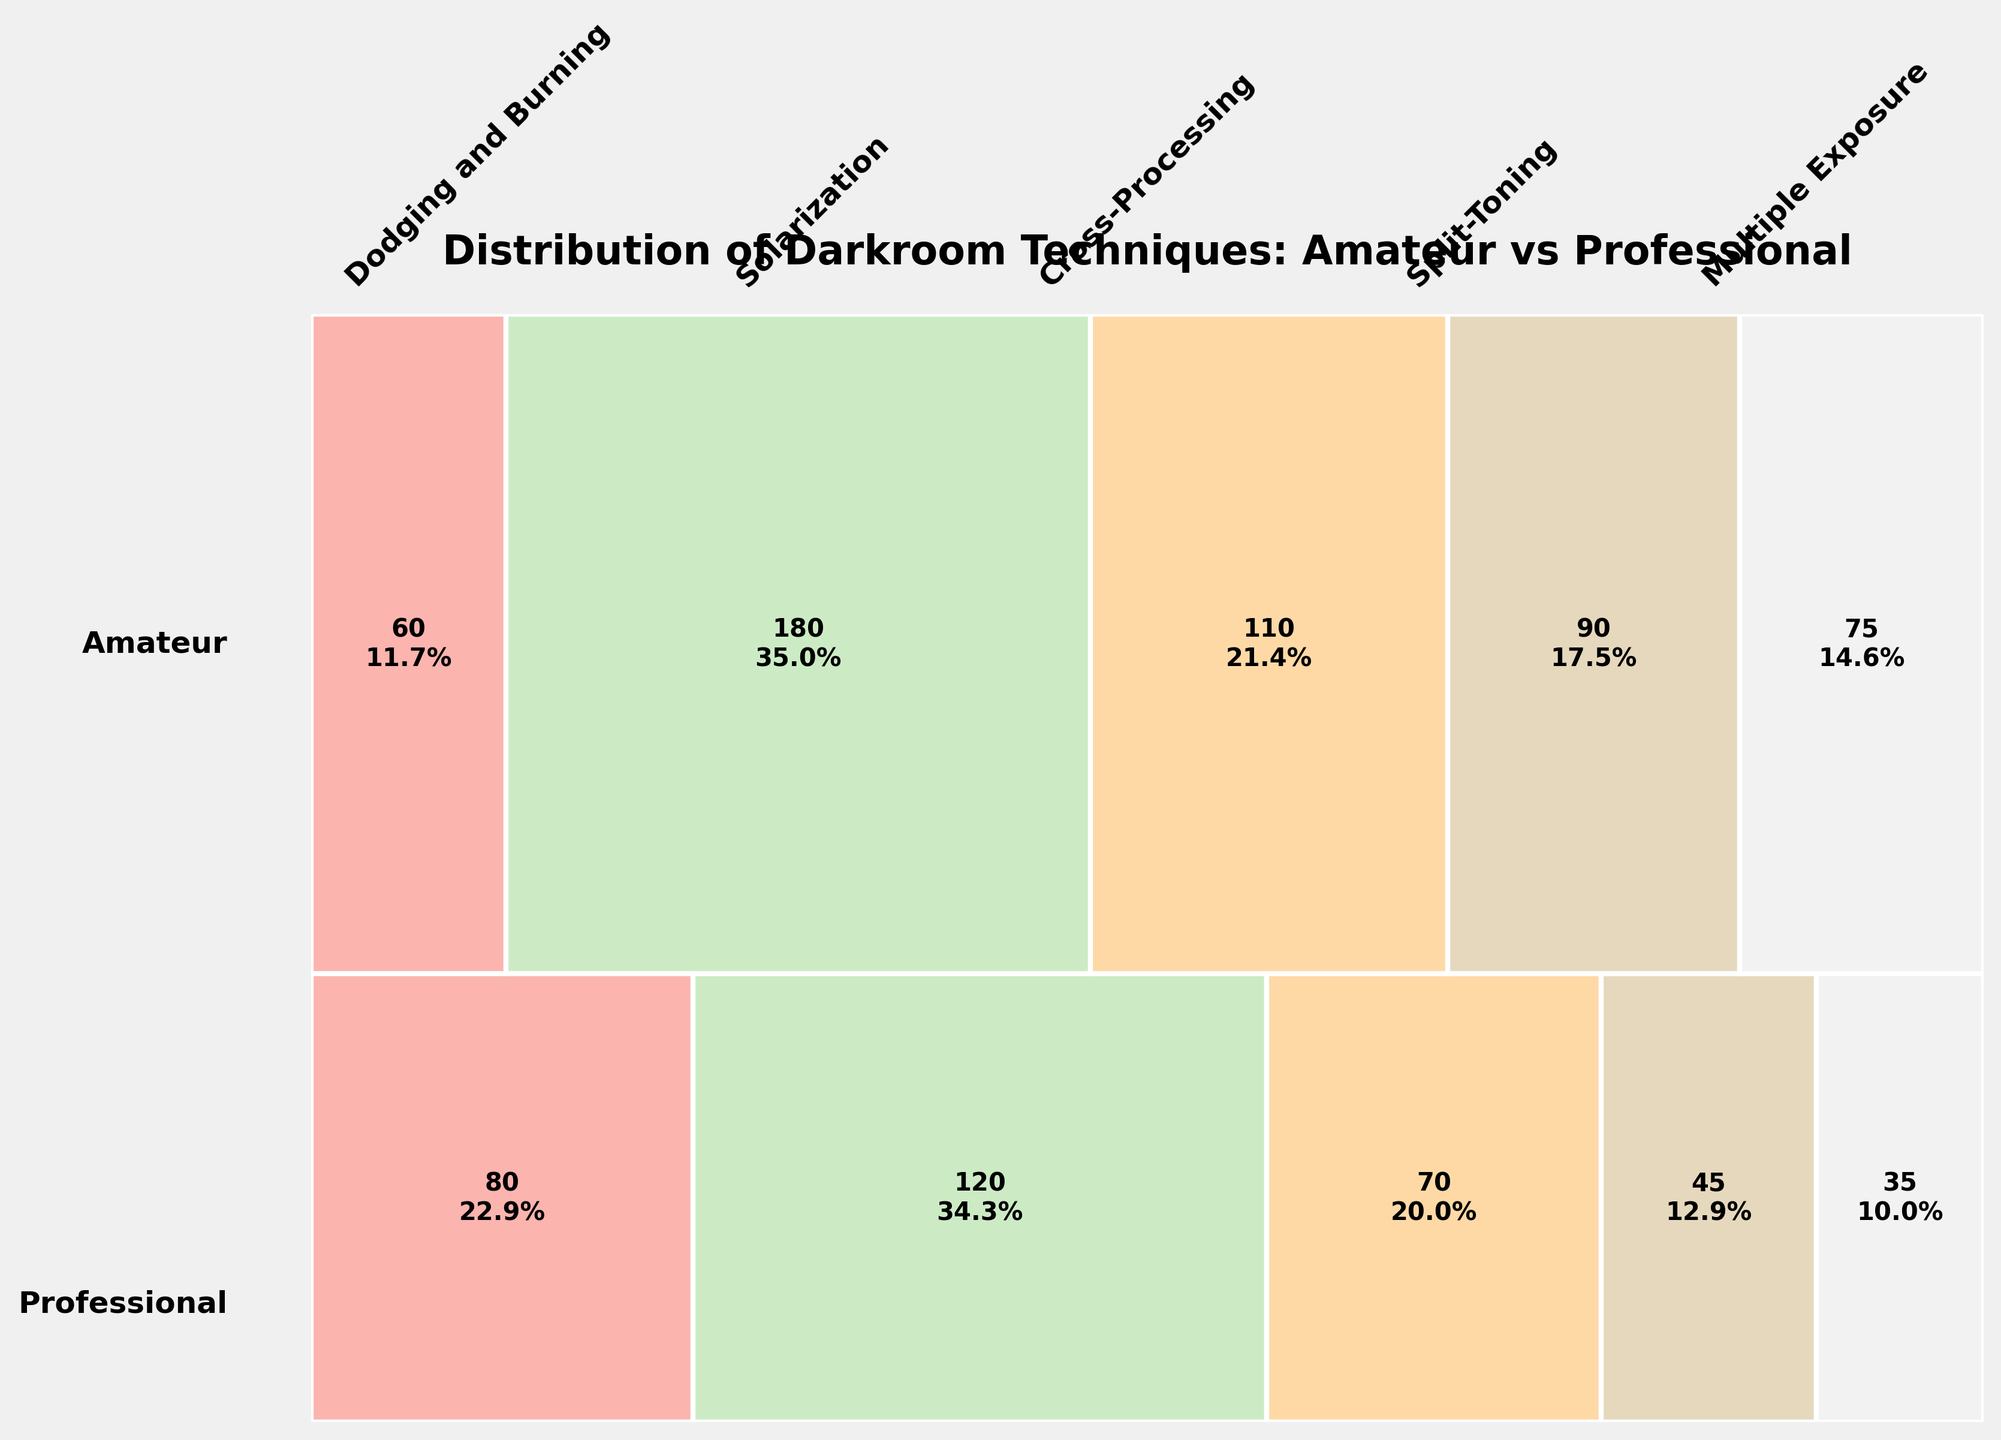How many photographers in total use the 'Multiple Exposure' technique? Sum the counts of 'Multiple Exposure' for both amateur and professional photographers: 70 (Amateur) + 110 (Professional)
Answer: 180 What is the title of the figure? The title is located at the top center of the figure in a larger, bold font.
Answer: Distribution of Darkroom Techniques: Amateur vs Professional Which technique is preferred more by amateurs compared to professionals? Look at each technique's proportion and count for both groups. 'Dodging and Burning' has a lower count for amateurs than professionals; 'Solarization' is higher for professionals; 'Cross-Processing' is higher for amateurs; 'Split-Toning' lower for amateurs; 'Multiple Exposure' lower for amateurs. Therefore, 'Cross-Processing' is preferred more by amateurs.
Answer: Cross-Processing What percentage of professional photographers use the 'Dodging and Burning' technique? Look at the rectangle representing 'Dodging and Burning' for professionals and find the percentage label inside the rectangle.
Answer: 45.7% Which group has a higher diversity of technique usage? Observing the width proportions for both amateur and professional groups, professionals display rectangles with more balance across different techniques, suggesting higher diversity.
Answer: Professionals How many more amateur photographers use 'Dodging and Burning' compared to 'Solarization'? Subtract the count for 'Solarization' from the count for 'Dodging and Burning' for amateurs: 120 (Dodging and Burning) - 45 (Solarization)
Answer: 75 What is the most popular technique among professional photographers? Identify the largest proportion rectangle within the professional group. The 'Dodging and Burning' rectangle is the largest.
Answer: Dodging and Burning What is the least popular technique among amateur photographers? Identify the smallest proportion rectangle within the amateur group. The 'Split-Toning' rectangle is the smallest.
Answer: Split-Toning 